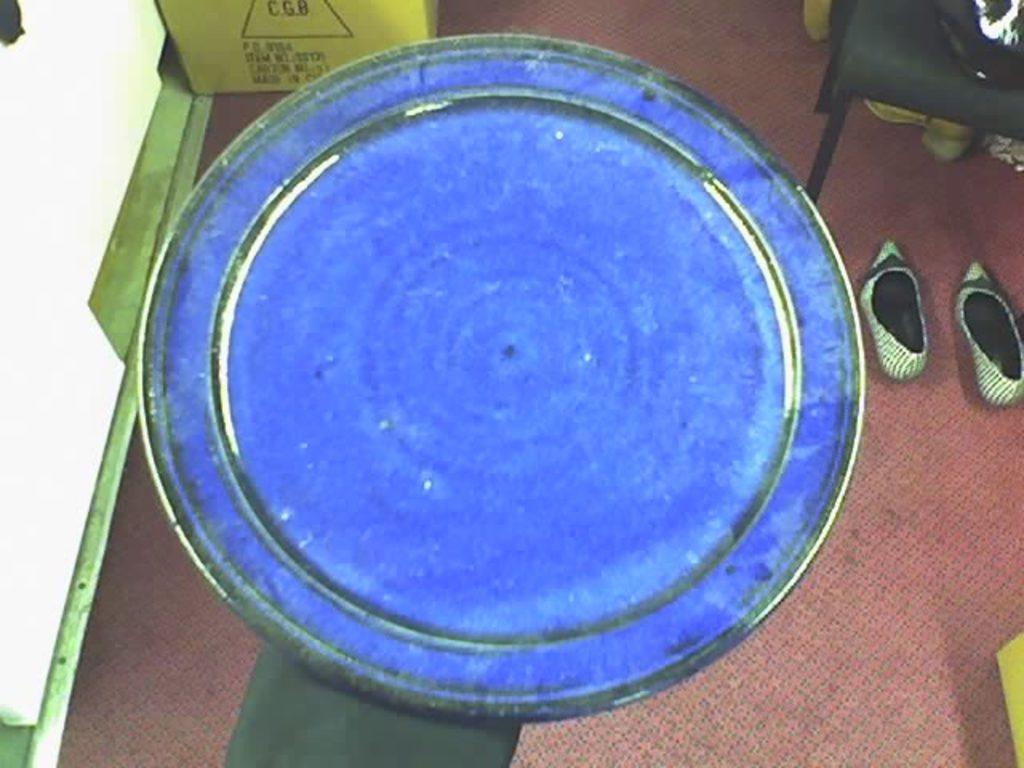In one or two sentences, can you explain what this image depicts? This picture seems to be clicked inside the room. In the center we can see a black color object and we can see the shoes and a box and some other objects are placed on the ground and we can see the text on the box and we can see some other objects. 